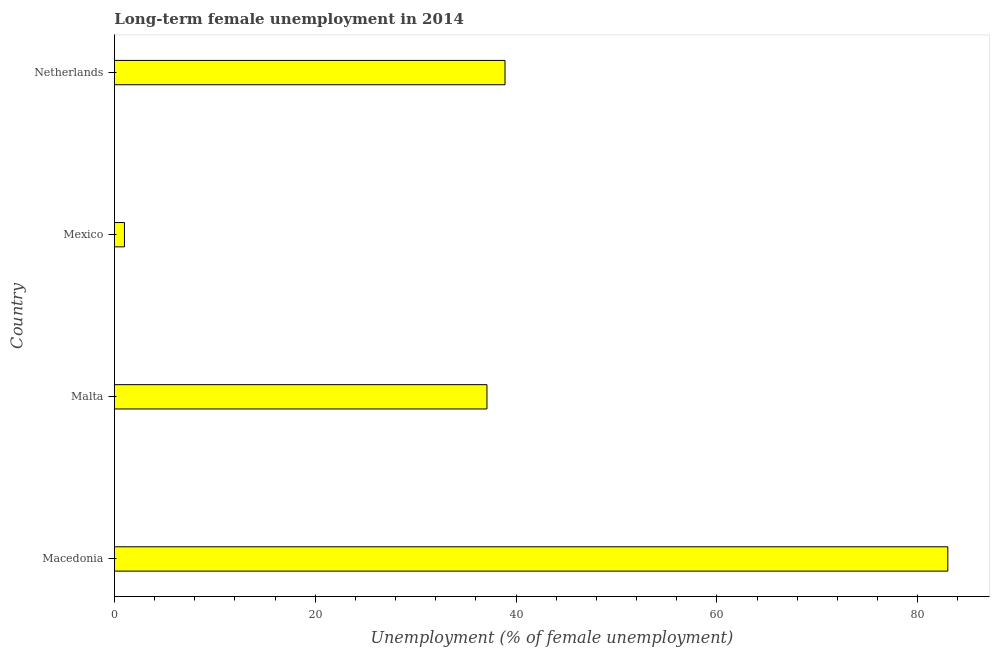What is the title of the graph?
Keep it short and to the point. Long-term female unemployment in 2014. What is the label or title of the X-axis?
Provide a succinct answer. Unemployment (% of female unemployment). What is the long-term female unemployment in Macedonia?
Offer a very short reply. 83. In which country was the long-term female unemployment maximum?
Keep it short and to the point. Macedonia. In which country was the long-term female unemployment minimum?
Your response must be concise. Mexico. What is the sum of the long-term female unemployment?
Provide a succinct answer. 160. What is the difference between the long-term female unemployment in Macedonia and Netherlands?
Your answer should be very brief. 44.1. What is the median long-term female unemployment?
Your answer should be very brief. 38. What is the ratio of the long-term female unemployment in Macedonia to that in Mexico?
Provide a succinct answer. 83. Is the long-term female unemployment in Malta less than that in Mexico?
Offer a terse response. No. Is the difference between the long-term female unemployment in Mexico and Netherlands greater than the difference between any two countries?
Provide a short and direct response. No. What is the difference between the highest and the second highest long-term female unemployment?
Provide a short and direct response. 44.1. Is the sum of the long-term female unemployment in Macedonia and Mexico greater than the maximum long-term female unemployment across all countries?
Your answer should be compact. Yes. What is the difference between the highest and the lowest long-term female unemployment?
Offer a terse response. 82. How many bars are there?
Offer a terse response. 4. Are all the bars in the graph horizontal?
Provide a short and direct response. Yes. How many countries are there in the graph?
Provide a short and direct response. 4. What is the Unemployment (% of female unemployment) of Macedonia?
Offer a very short reply. 83. What is the Unemployment (% of female unemployment) in Malta?
Make the answer very short. 37.1. What is the Unemployment (% of female unemployment) of Mexico?
Your response must be concise. 1. What is the Unemployment (% of female unemployment) of Netherlands?
Give a very brief answer. 38.9. What is the difference between the Unemployment (% of female unemployment) in Macedonia and Malta?
Make the answer very short. 45.9. What is the difference between the Unemployment (% of female unemployment) in Macedonia and Mexico?
Keep it short and to the point. 82. What is the difference between the Unemployment (% of female unemployment) in Macedonia and Netherlands?
Make the answer very short. 44.1. What is the difference between the Unemployment (% of female unemployment) in Malta and Mexico?
Your answer should be very brief. 36.1. What is the difference between the Unemployment (% of female unemployment) in Mexico and Netherlands?
Keep it short and to the point. -37.9. What is the ratio of the Unemployment (% of female unemployment) in Macedonia to that in Malta?
Your answer should be compact. 2.24. What is the ratio of the Unemployment (% of female unemployment) in Macedonia to that in Mexico?
Provide a succinct answer. 83. What is the ratio of the Unemployment (% of female unemployment) in Macedonia to that in Netherlands?
Ensure brevity in your answer.  2.13. What is the ratio of the Unemployment (% of female unemployment) in Malta to that in Mexico?
Keep it short and to the point. 37.1. What is the ratio of the Unemployment (% of female unemployment) in Malta to that in Netherlands?
Ensure brevity in your answer.  0.95. What is the ratio of the Unemployment (% of female unemployment) in Mexico to that in Netherlands?
Provide a short and direct response. 0.03. 